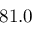<formula> <loc_0><loc_0><loc_500><loc_500>8 1 . 0</formula> 